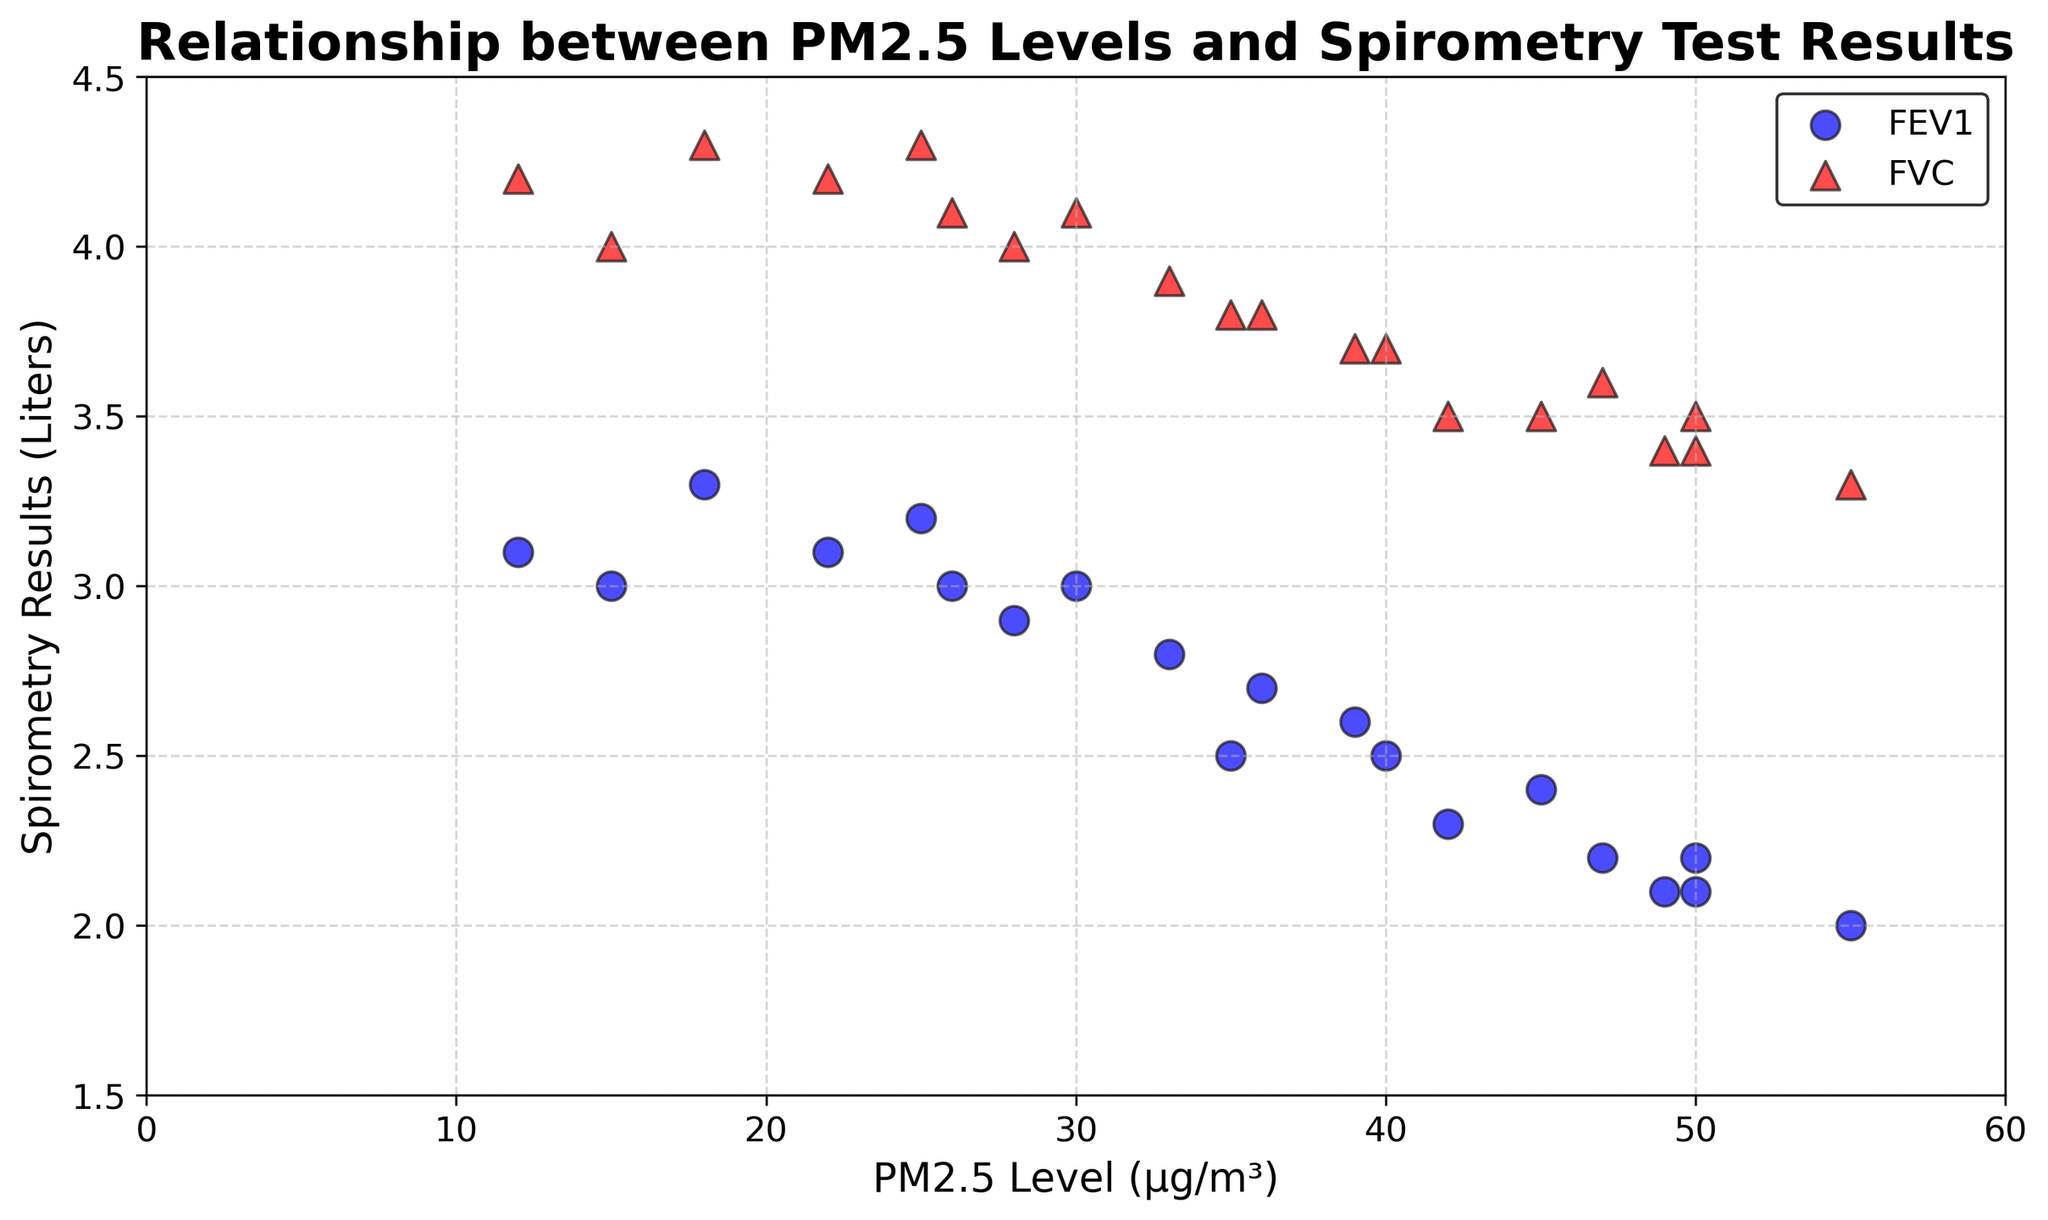What is the relationship between PM2.5 levels and FEV1 values? The plot shows a negative correlation between PM2.5 levels and FEV1 values, indicating that as PM2.5 levels increase, FEV1 values tend to decrease. This can be visually assessed by observing that higher PM2.5 values correspond to lower FEV1 data points (blue circles).
Answer: Negative correlation What is the average FVC value for PM2.5 levels above 40 µg/m³? First, identify the FVC values where PM2.5 levels are above 40 µg/m³: 3.4, 3.5, 3.3, 3.6, 3.5. Sum these values: 3.4 + 3.5 + 3.3 + 3.6 + 3.5 = 17.3. Then, divide by the number of data points (5): 17.3 / 5 = 3.46.
Answer: 3.46 Which spirometry test (FEV1 or FVC) shows a more noticeable trend with PM2.5 levels? FEV1 shows a more noticeable negative trend with increasing PM2.5 levels. This is visually identified by the consistent downward slope of FEV1 values (blue circles) as PM2.5 levels rise, compared to the relatively less pronounced decrease in FVC values (red triangles).
Answer: FEV1 How many patients have FEV1 values below 2.5 liters? Count the number of blue circles below the 2.5 liters mark on the y-axis. These correspond to patients 2, 5, 7, 9, 13, 16, and 20. Therefore, there are 7 patients.
Answer: 7 Is there a patient with a PM2.5 level of 40 µg/m³? If so, what are their spirometry results? By examining the scatter plot, identify the data point where PM2.5 level equals 40 µg/m³. There is one such patient, and their spirometry results are FEV1 = 2.5 liters and FVC = 3.7 liters.
Answer: Yes, FEV1 = 2.5, FVC = 3.7 What is the range of FEV1 values observed in the data? To find the range, identify the minimum and maximum FEV1 values. The minimum FEV1 is 2.0 liters (Patient 7), and the maximum is 3.3 liters (Patient 17). The range is therefore 3.3 - 2.0 = 1.3 liters.
Answer: 1.3 liters How does the PM2.5 level of the patient with the highest FEV1 value compare to the patient with the lowest FEV1 value? Identify the patients: the highest FEV1 (3.3 liters) corresponds to Patient 17 with a PM2.5 level of 18 µg/m³, and the lowest FEV1 (2.0 liters) corresponds to Patient 7 with a PM2.5 level of 55 µg/m³. The patient with the lowest FEV1 has a much higher PM2.5 level compared to the patient with the highest FEV1.
Answer: Much higher 